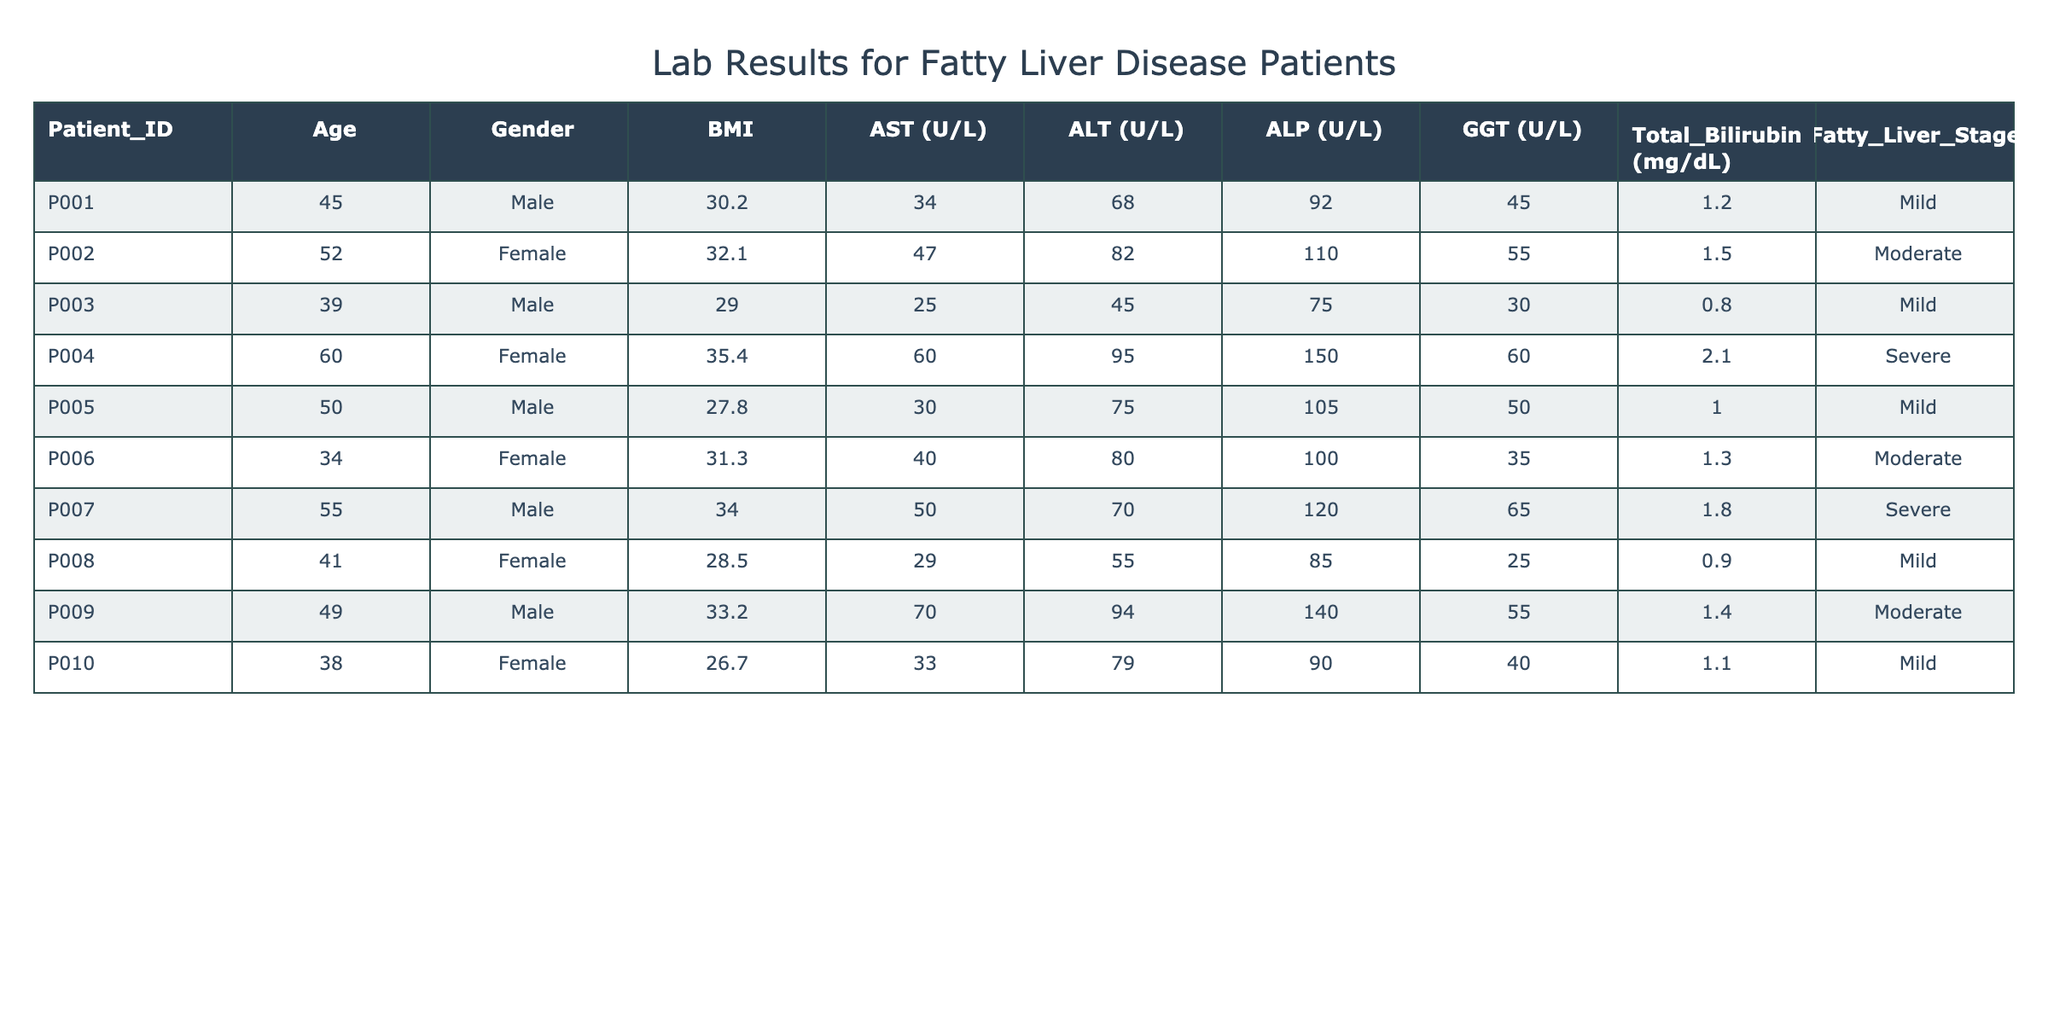What is the AST level for Patient P006? The table shows the AST level for each patient under the AST (U/L) column. By locating Patient P006 in the Patient_ID column, we observe that the corresponding AST level is 40.
Answer: 40 What is the highest ALT value recorded in the table? By scanning the ALT (U/L) column, the values are 68, 82, 45, 95, 75, 80, 70, 55, 94, and 79. The maximum value from this set is 95, found for Patient P004.
Answer: 95 How many patients are classified as having severe fatty liver disease? The Fatty_Liver_Stage column shows three entries marked as "Severe" which are for Patient P004, P007, and P008. Thus, there are three patients in total.
Answer: 3 What is the average GGT level among the patients in the mild fatty liver stage? The GGT levels for patients in the mild stage (Patient P001, P003, P005, P008, P010) are 92, 75, 105, 85, and 90. Adding these values (92 + 75 + 105 + 85 + 90 = 447) and dividing by 5 gives the average GGT level of 89.4.
Answer: 89.4 Is there a patient with a Total Bilirubin level above 1.5 mg/dL? By examining the Total_Bilirubin (mg/dL) column, we can see that only Patient P004 has a level of 2.1 mg/dL which exceeds 1.5. Therefore, the answer is yes.
Answer: Yes Which patient has the lowest BMI and what is their corresponding Fatty Liver Stage? Looking through the BMI column, Patient P010 has the lowest BMI of 26.7, and we can find that this patient is categorized in the Mild stage.
Answer: Patient P010, Mild What is the difference in the ALT levels between the patients with the highest and lowest ALT values? The highest ALT is 95 for Patient P004 and the lowest is 45 for Patient P003. The difference is thus calculated as 95 - 45 = 50.
Answer: 50 How many patients are females, and what is the average AST level for them? From the gender column, the female patients are P002, P004, P006, P010, totaling four females. The AST levels for these patients are 47, 60, 40, and 33. The average is calculated as (47 + 60 + 40 + 33) / 4 = 45.
Answer: 45 Are there any patients with an AST value less than 30? By inspecting the AST levels: 34, 47, 25, 60, 30, 40, 50, 29, 70, and 33, we see that the minimum value (25) for Patient P003 is less than 30. Thus, the answer is yes.
Answer: Yes 